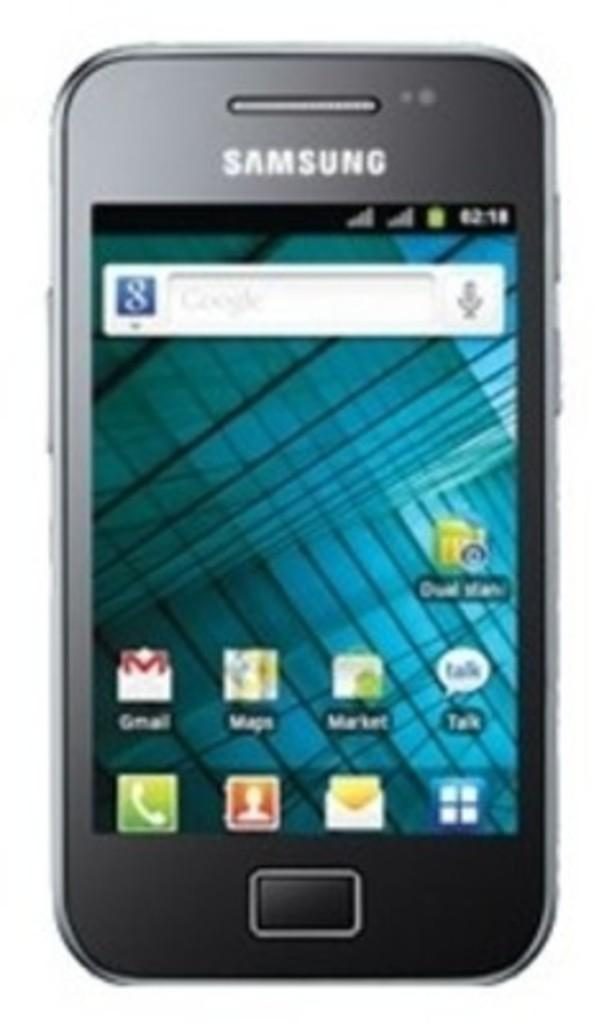<image>
Present a compact description of the photo's key features. A close up of a Samsung Android phone over a white background. 